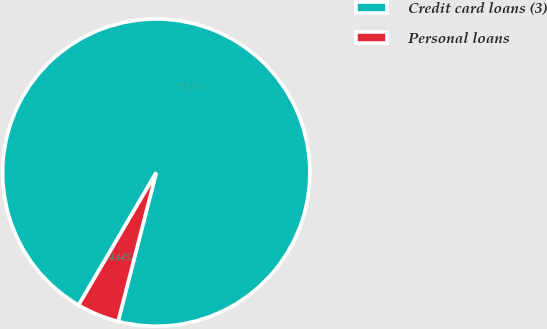Convert chart. <chart><loc_0><loc_0><loc_500><loc_500><pie_chart><fcel>Credit card loans (3)<fcel>Personal loans<nl><fcel>95.56%<fcel>4.44%<nl></chart> 